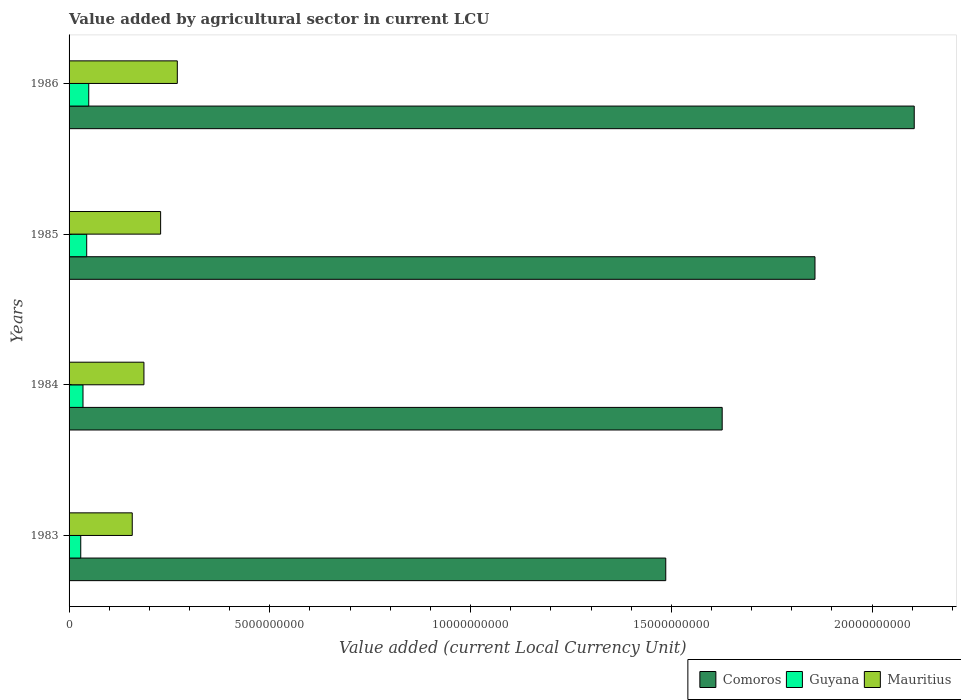How many different coloured bars are there?
Your answer should be very brief. 3. In how many cases, is the number of bars for a given year not equal to the number of legend labels?
Make the answer very short. 0. What is the value added by agricultural sector in Mauritius in 1985?
Your answer should be very brief. 2.28e+09. Across all years, what is the maximum value added by agricultural sector in Guyana?
Ensure brevity in your answer.  4.90e+08. Across all years, what is the minimum value added by agricultural sector in Guyana?
Your answer should be very brief. 2.91e+08. In which year was the value added by agricultural sector in Comoros maximum?
Your answer should be very brief. 1986. What is the total value added by agricultural sector in Comoros in the graph?
Give a very brief answer. 7.08e+1. What is the difference between the value added by agricultural sector in Comoros in 1985 and that in 1986?
Provide a succinct answer. -2.47e+09. What is the difference between the value added by agricultural sector in Mauritius in 1983 and the value added by agricultural sector in Comoros in 1986?
Provide a short and direct response. -1.95e+1. What is the average value added by agricultural sector in Comoros per year?
Your answer should be compact. 1.77e+1. In the year 1984, what is the difference between the value added by agricultural sector in Mauritius and value added by agricultural sector in Guyana?
Your response must be concise. 1.52e+09. In how many years, is the value added by agricultural sector in Comoros greater than 15000000000 LCU?
Offer a very short reply. 3. What is the ratio of the value added by agricultural sector in Comoros in 1984 to that in 1986?
Provide a short and direct response. 0.77. Is the value added by agricultural sector in Guyana in 1983 less than that in 1985?
Offer a very short reply. Yes. What is the difference between the highest and the second highest value added by agricultural sector in Comoros?
Make the answer very short. 2.47e+09. What is the difference between the highest and the lowest value added by agricultural sector in Mauritius?
Provide a short and direct response. 1.12e+09. In how many years, is the value added by agricultural sector in Comoros greater than the average value added by agricultural sector in Comoros taken over all years?
Provide a short and direct response. 2. What does the 1st bar from the top in 1983 represents?
Keep it short and to the point. Mauritius. What does the 1st bar from the bottom in 1983 represents?
Offer a terse response. Comoros. Is it the case that in every year, the sum of the value added by agricultural sector in Comoros and value added by agricultural sector in Mauritius is greater than the value added by agricultural sector in Guyana?
Your answer should be compact. Yes. Are all the bars in the graph horizontal?
Provide a succinct answer. Yes. How many years are there in the graph?
Your response must be concise. 4. Does the graph contain any zero values?
Keep it short and to the point. No. How are the legend labels stacked?
Keep it short and to the point. Horizontal. What is the title of the graph?
Offer a very short reply. Value added by agricultural sector in current LCU. Does "Fragile and conflict affected situations" appear as one of the legend labels in the graph?
Give a very brief answer. No. What is the label or title of the X-axis?
Your response must be concise. Value added (current Local Currency Unit). What is the Value added (current Local Currency Unit) in Comoros in 1983?
Give a very brief answer. 1.49e+1. What is the Value added (current Local Currency Unit) in Guyana in 1983?
Offer a very short reply. 2.91e+08. What is the Value added (current Local Currency Unit) of Mauritius in 1983?
Give a very brief answer. 1.57e+09. What is the Value added (current Local Currency Unit) in Comoros in 1984?
Provide a short and direct response. 1.63e+1. What is the Value added (current Local Currency Unit) in Guyana in 1984?
Your response must be concise. 3.47e+08. What is the Value added (current Local Currency Unit) in Mauritius in 1984?
Your answer should be compact. 1.86e+09. What is the Value added (current Local Currency Unit) of Comoros in 1985?
Make the answer very short. 1.86e+1. What is the Value added (current Local Currency Unit) of Guyana in 1985?
Provide a succinct answer. 4.39e+08. What is the Value added (current Local Currency Unit) of Mauritius in 1985?
Ensure brevity in your answer.  2.28e+09. What is the Value added (current Local Currency Unit) of Comoros in 1986?
Your response must be concise. 2.10e+1. What is the Value added (current Local Currency Unit) of Guyana in 1986?
Provide a short and direct response. 4.90e+08. What is the Value added (current Local Currency Unit) of Mauritius in 1986?
Your answer should be very brief. 2.70e+09. Across all years, what is the maximum Value added (current Local Currency Unit) in Comoros?
Ensure brevity in your answer.  2.10e+1. Across all years, what is the maximum Value added (current Local Currency Unit) of Guyana?
Provide a short and direct response. 4.90e+08. Across all years, what is the maximum Value added (current Local Currency Unit) in Mauritius?
Your response must be concise. 2.70e+09. Across all years, what is the minimum Value added (current Local Currency Unit) in Comoros?
Your answer should be very brief. 1.49e+1. Across all years, what is the minimum Value added (current Local Currency Unit) in Guyana?
Your answer should be compact. 2.91e+08. Across all years, what is the minimum Value added (current Local Currency Unit) in Mauritius?
Your response must be concise. 1.57e+09. What is the total Value added (current Local Currency Unit) in Comoros in the graph?
Make the answer very short. 7.08e+1. What is the total Value added (current Local Currency Unit) of Guyana in the graph?
Offer a terse response. 1.57e+09. What is the total Value added (current Local Currency Unit) of Mauritius in the graph?
Keep it short and to the point. 8.41e+09. What is the difference between the Value added (current Local Currency Unit) of Comoros in 1983 and that in 1984?
Your response must be concise. -1.41e+09. What is the difference between the Value added (current Local Currency Unit) of Guyana in 1983 and that in 1984?
Make the answer very short. -5.60e+07. What is the difference between the Value added (current Local Currency Unit) in Mauritius in 1983 and that in 1984?
Offer a very short reply. -2.91e+08. What is the difference between the Value added (current Local Currency Unit) in Comoros in 1983 and that in 1985?
Give a very brief answer. -3.72e+09. What is the difference between the Value added (current Local Currency Unit) of Guyana in 1983 and that in 1985?
Offer a terse response. -1.48e+08. What is the difference between the Value added (current Local Currency Unit) of Mauritius in 1983 and that in 1985?
Your answer should be very brief. -7.07e+08. What is the difference between the Value added (current Local Currency Unit) of Comoros in 1983 and that in 1986?
Provide a succinct answer. -6.19e+09. What is the difference between the Value added (current Local Currency Unit) of Guyana in 1983 and that in 1986?
Offer a terse response. -1.99e+08. What is the difference between the Value added (current Local Currency Unit) of Mauritius in 1983 and that in 1986?
Your answer should be very brief. -1.12e+09. What is the difference between the Value added (current Local Currency Unit) of Comoros in 1984 and that in 1985?
Make the answer very short. -2.31e+09. What is the difference between the Value added (current Local Currency Unit) in Guyana in 1984 and that in 1985?
Offer a terse response. -9.20e+07. What is the difference between the Value added (current Local Currency Unit) in Mauritius in 1984 and that in 1985?
Provide a short and direct response. -4.16e+08. What is the difference between the Value added (current Local Currency Unit) of Comoros in 1984 and that in 1986?
Make the answer very short. -4.78e+09. What is the difference between the Value added (current Local Currency Unit) in Guyana in 1984 and that in 1986?
Give a very brief answer. -1.43e+08. What is the difference between the Value added (current Local Currency Unit) in Mauritius in 1984 and that in 1986?
Provide a succinct answer. -8.31e+08. What is the difference between the Value added (current Local Currency Unit) in Comoros in 1985 and that in 1986?
Make the answer very short. -2.47e+09. What is the difference between the Value added (current Local Currency Unit) of Guyana in 1985 and that in 1986?
Make the answer very short. -5.10e+07. What is the difference between the Value added (current Local Currency Unit) of Mauritius in 1985 and that in 1986?
Give a very brief answer. -4.16e+08. What is the difference between the Value added (current Local Currency Unit) in Comoros in 1983 and the Value added (current Local Currency Unit) in Guyana in 1984?
Provide a succinct answer. 1.45e+1. What is the difference between the Value added (current Local Currency Unit) of Comoros in 1983 and the Value added (current Local Currency Unit) of Mauritius in 1984?
Keep it short and to the point. 1.30e+1. What is the difference between the Value added (current Local Currency Unit) of Guyana in 1983 and the Value added (current Local Currency Unit) of Mauritius in 1984?
Your answer should be very brief. -1.57e+09. What is the difference between the Value added (current Local Currency Unit) in Comoros in 1983 and the Value added (current Local Currency Unit) in Guyana in 1985?
Offer a terse response. 1.44e+1. What is the difference between the Value added (current Local Currency Unit) in Comoros in 1983 and the Value added (current Local Currency Unit) in Mauritius in 1985?
Provide a succinct answer. 1.26e+1. What is the difference between the Value added (current Local Currency Unit) in Guyana in 1983 and the Value added (current Local Currency Unit) in Mauritius in 1985?
Offer a very short reply. -1.99e+09. What is the difference between the Value added (current Local Currency Unit) of Comoros in 1983 and the Value added (current Local Currency Unit) of Guyana in 1986?
Keep it short and to the point. 1.44e+1. What is the difference between the Value added (current Local Currency Unit) in Comoros in 1983 and the Value added (current Local Currency Unit) in Mauritius in 1986?
Ensure brevity in your answer.  1.22e+1. What is the difference between the Value added (current Local Currency Unit) in Guyana in 1983 and the Value added (current Local Currency Unit) in Mauritius in 1986?
Give a very brief answer. -2.40e+09. What is the difference between the Value added (current Local Currency Unit) in Comoros in 1984 and the Value added (current Local Currency Unit) in Guyana in 1985?
Your answer should be very brief. 1.58e+1. What is the difference between the Value added (current Local Currency Unit) in Comoros in 1984 and the Value added (current Local Currency Unit) in Mauritius in 1985?
Offer a terse response. 1.40e+1. What is the difference between the Value added (current Local Currency Unit) in Guyana in 1984 and the Value added (current Local Currency Unit) in Mauritius in 1985?
Provide a short and direct response. -1.93e+09. What is the difference between the Value added (current Local Currency Unit) in Comoros in 1984 and the Value added (current Local Currency Unit) in Guyana in 1986?
Your answer should be very brief. 1.58e+1. What is the difference between the Value added (current Local Currency Unit) of Comoros in 1984 and the Value added (current Local Currency Unit) of Mauritius in 1986?
Your answer should be compact. 1.36e+1. What is the difference between the Value added (current Local Currency Unit) in Guyana in 1984 and the Value added (current Local Currency Unit) in Mauritius in 1986?
Give a very brief answer. -2.35e+09. What is the difference between the Value added (current Local Currency Unit) in Comoros in 1985 and the Value added (current Local Currency Unit) in Guyana in 1986?
Provide a short and direct response. 1.81e+1. What is the difference between the Value added (current Local Currency Unit) of Comoros in 1985 and the Value added (current Local Currency Unit) of Mauritius in 1986?
Offer a terse response. 1.59e+1. What is the difference between the Value added (current Local Currency Unit) in Guyana in 1985 and the Value added (current Local Currency Unit) in Mauritius in 1986?
Provide a succinct answer. -2.26e+09. What is the average Value added (current Local Currency Unit) in Comoros per year?
Your answer should be very brief. 1.77e+1. What is the average Value added (current Local Currency Unit) of Guyana per year?
Ensure brevity in your answer.  3.92e+08. What is the average Value added (current Local Currency Unit) of Mauritius per year?
Your answer should be very brief. 2.10e+09. In the year 1983, what is the difference between the Value added (current Local Currency Unit) of Comoros and Value added (current Local Currency Unit) of Guyana?
Your response must be concise. 1.46e+1. In the year 1983, what is the difference between the Value added (current Local Currency Unit) of Comoros and Value added (current Local Currency Unit) of Mauritius?
Offer a very short reply. 1.33e+1. In the year 1983, what is the difference between the Value added (current Local Currency Unit) in Guyana and Value added (current Local Currency Unit) in Mauritius?
Provide a short and direct response. -1.28e+09. In the year 1984, what is the difference between the Value added (current Local Currency Unit) in Comoros and Value added (current Local Currency Unit) in Guyana?
Make the answer very short. 1.59e+1. In the year 1984, what is the difference between the Value added (current Local Currency Unit) in Comoros and Value added (current Local Currency Unit) in Mauritius?
Ensure brevity in your answer.  1.44e+1. In the year 1984, what is the difference between the Value added (current Local Currency Unit) in Guyana and Value added (current Local Currency Unit) in Mauritius?
Give a very brief answer. -1.52e+09. In the year 1985, what is the difference between the Value added (current Local Currency Unit) in Comoros and Value added (current Local Currency Unit) in Guyana?
Ensure brevity in your answer.  1.81e+1. In the year 1985, what is the difference between the Value added (current Local Currency Unit) in Comoros and Value added (current Local Currency Unit) in Mauritius?
Keep it short and to the point. 1.63e+1. In the year 1985, what is the difference between the Value added (current Local Currency Unit) in Guyana and Value added (current Local Currency Unit) in Mauritius?
Offer a terse response. -1.84e+09. In the year 1986, what is the difference between the Value added (current Local Currency Unit) in Comoros and Value added (current Local Currency Unit) in Guyana?
Provide a succinct answer. 2.06e+1. In the year 1986, what is the difference between the Value added (current Local Currency Unit) of Comoros and Value added (current Local Currency Unit) of Mauritius?
Keep it short and to the point. 1.84e+1. In the year 1986, what is the difference between the Value added (current Local Currency Unit) of Guyana and Value added (current Local Currency Unit) of Mauritius?
Provide a short and direct response. -2.21e+09. What is the ratio of the Value added (current Local Currency Unit) in Comoros in 1983 to that in 1984?
Give a very brief answer. 0.91. What is the ratio of the Value added (current Local Currency Unit) of Guyana in 1983 to that in 1984?
Ensure brevity in your answer.  0.84. What is the ratio of the Value added (current Local Currency Unit) of Mauritius in 1983 to that in 1984?
Make the answer very short. 0.84. What is the ratio of the Value added (current Local Currency Unit) in Comoros in 1983 to that in 1985?
Offer a very short reply. 0.8. What is the ratio of the Value added (current Local Currency Unit) in Guyana in 1983 to that in 1985?
Offer a terse response. 0.66. What is the ratio of the Value added (current Local Currency Unit) in Mauritius in 1983 to that in 1985?
Offer a terse response. 0.69. What is the ratio of the Value added (current Local Currency Unit) in Comoros in 1983 to that in 1986?
Your answer should be compact. 0.71. What is the ratio of the Value added (current Local Currency Unit) of Guyana in 1983 to that in 1986?
Provide a succinct answer. 0.59. What is the ratio of the Value added (current Local Currency Unit) of Mauritius in 1983 to that in 1986?
Ensure brevity in your answer.  0.58. What is the ratio of the Value added (current Local Currency Unit) in Comoros in 1984 to that in 1985?
Offer a very short reply. 0.88. What is the ratio of the Value added (current Local Currency Unit) in Guyana in 1984 to that in 1985?
Ensure brevity in your answer.  0.79. What is the ratio of the Value added (current Local Currency Unit) in Mauritius in 1984 to that in 1985?
Make the answer very short. 0.82. What is the ratio of the Value added (current Local Currency Unit) of Comoros in 1984 to that in 1986?
Provide a short and direct response. 0.77. What is the ratio of the Value added (current Local Currency Unit) of Guyana in 1984 to that in 1986?
Offer a very short reply. 0.71. What is the ratio of the Value added (current Local Currency Unit) in Mauritius in 1984 to that in 1986?
Offer a terse response. 0.69. What is the ratio of the Value added (current Local Currency Unit) in Comoros in 1985 to that in 1986?
Give a very brief answer. 0.88. What is the ratio of the Value added (current Local Currency Unit) in Guyana in 1985 to that in 1986?
Ensure brevity in your answer.  0.9. What is the ratio of the Value added (current Local Currency Unit) of Mauritius in 1985 to that in 1986?
Make the answer very short. 0.85. What is the difference between the highest and the second highest Value added (current Local Currency Unit) in Comoros?
Give a very brief answer. 2.47e+09. What is the difference between the highest and the second highest Value added (current Local Currency Unit) in Guyana?
Keep it short and to the point. 5.10e+07. What is the difference between the highest and the second highest Value added (current Local Currency Unit) in Mauritius?
Your answer should be compact. 4.16e+08. What is the difference between the highest and the lowest Value added (current Local Currency Unit) of Comoros?
Make the answer very short. 6.19e+09. What is the difference between the highest and the lowest Value added (current Local Currency Unit) in Guyana?
Provide a short and direct response. 1.99e+08. What is the difference between the highest and the lowest Value added (current Local Currency Unit) of Mauritius?
Provide a short and direct response. 1.12e+09. 